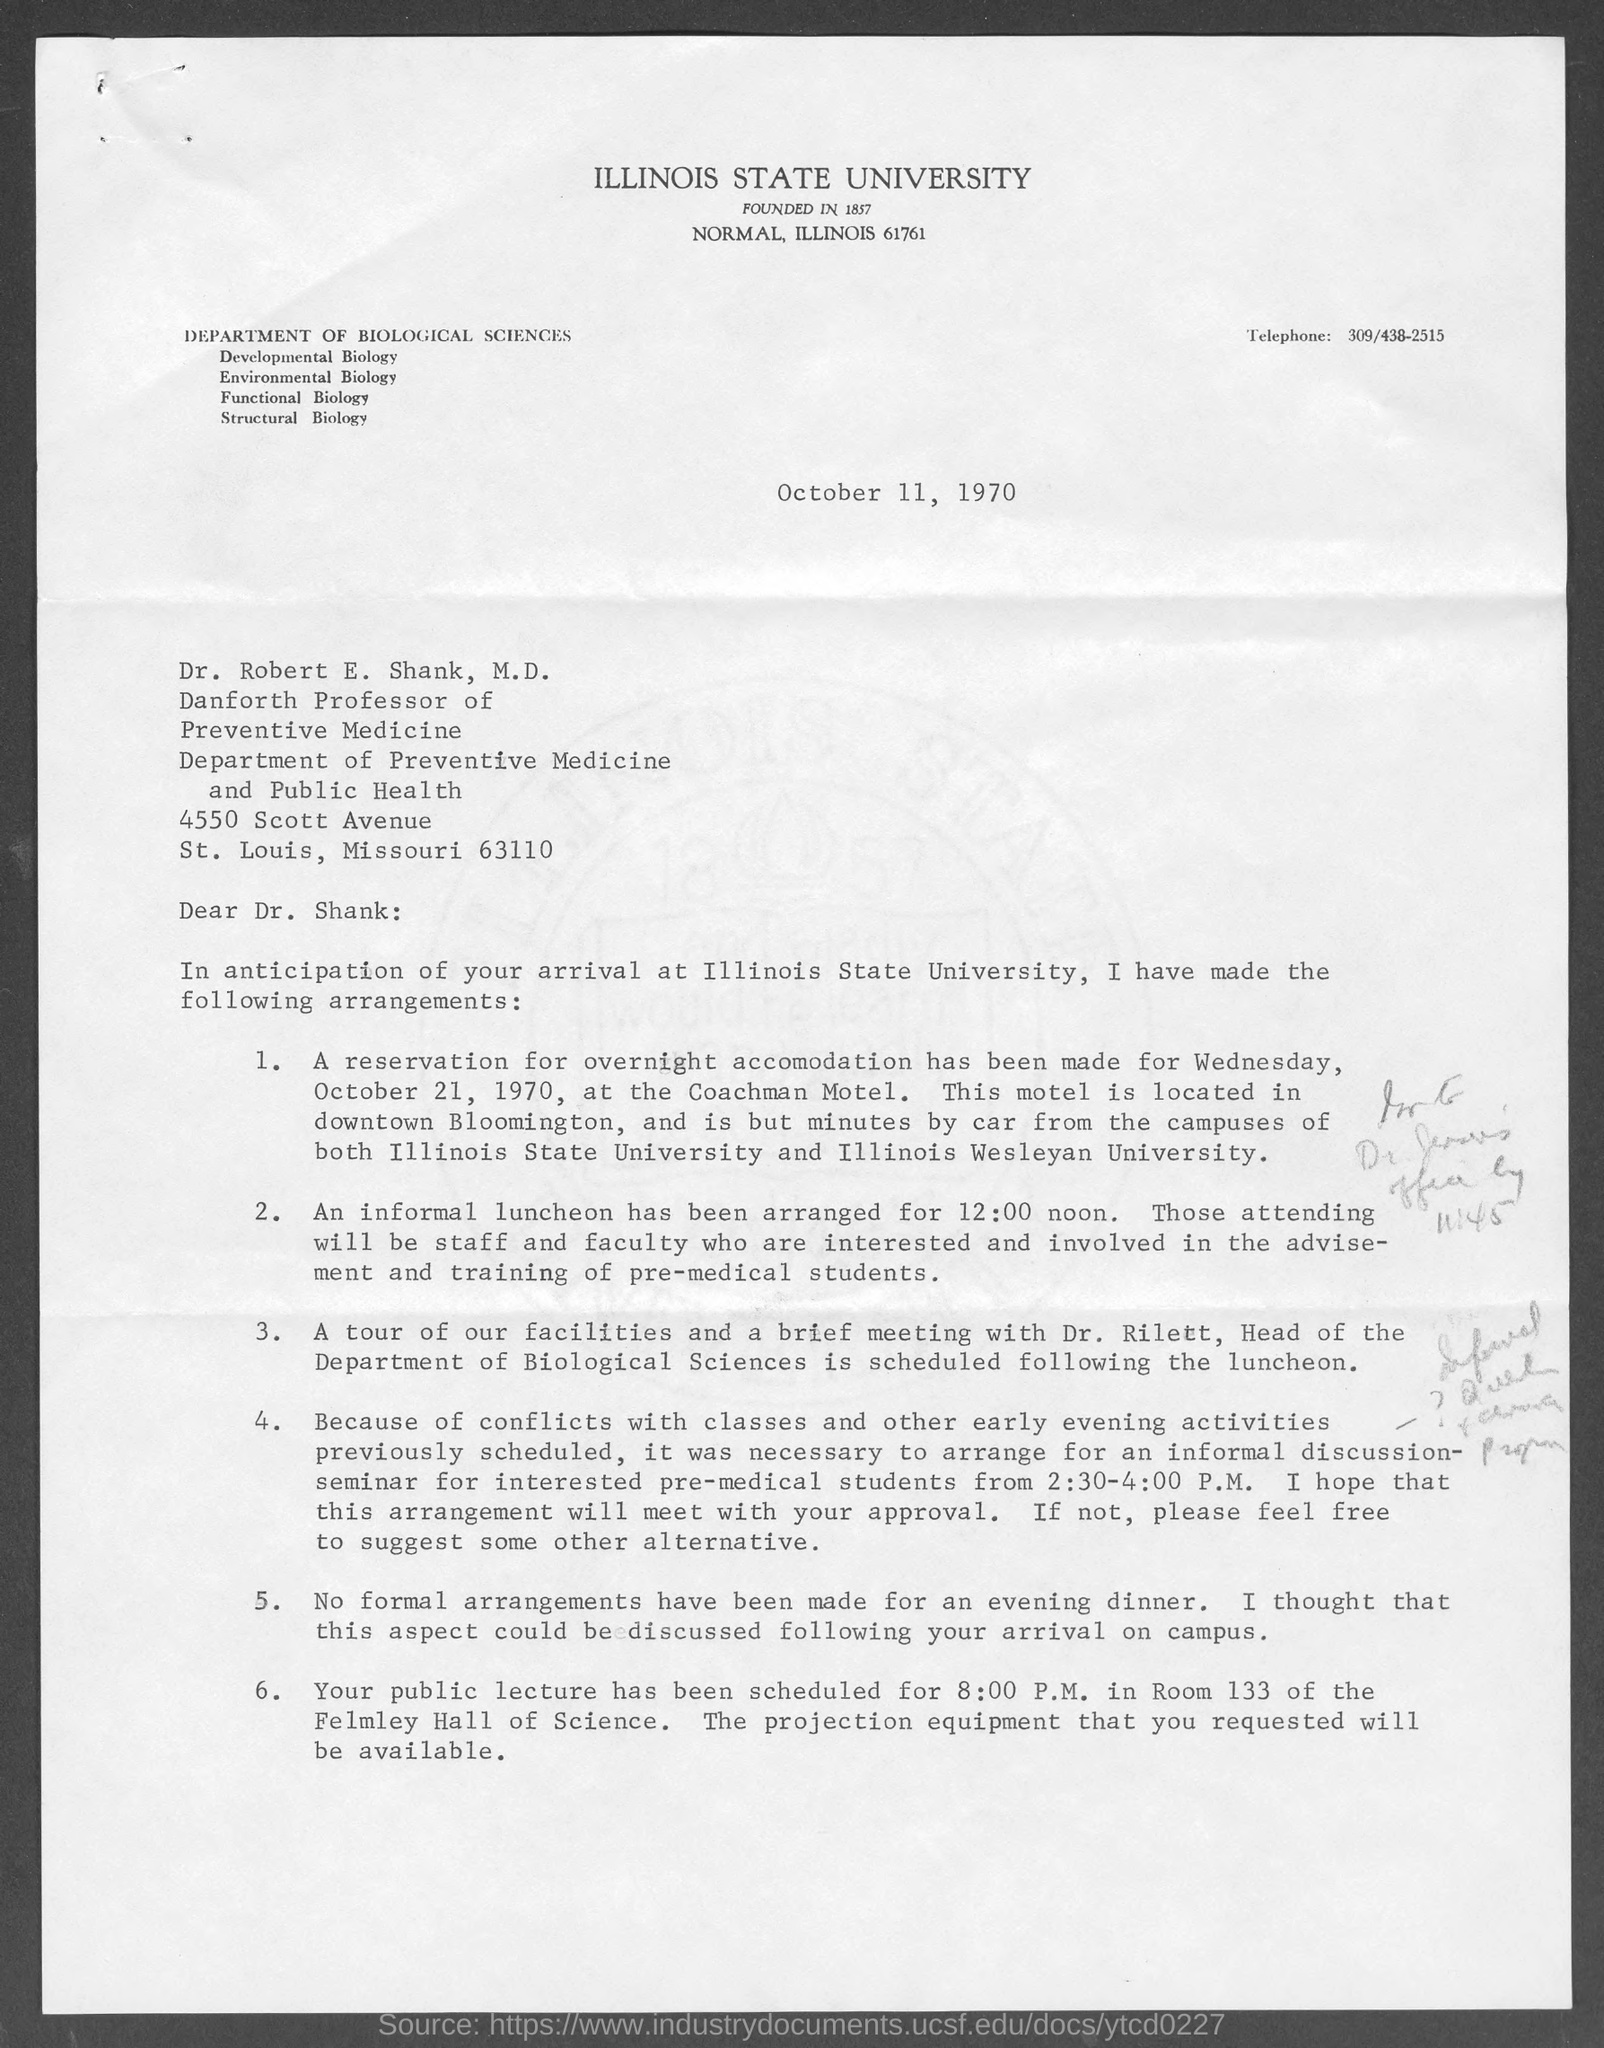Indicate a few pertinent items in this graphic. The telephone number is 309/438-2515. The date mentioned at the top of the document is October 11, 1970. 